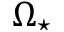Convert formula to latex. <formula><loc_0><loc_0><loc_500><loc_500>\Omega _ { ^ { * } }</formula> 